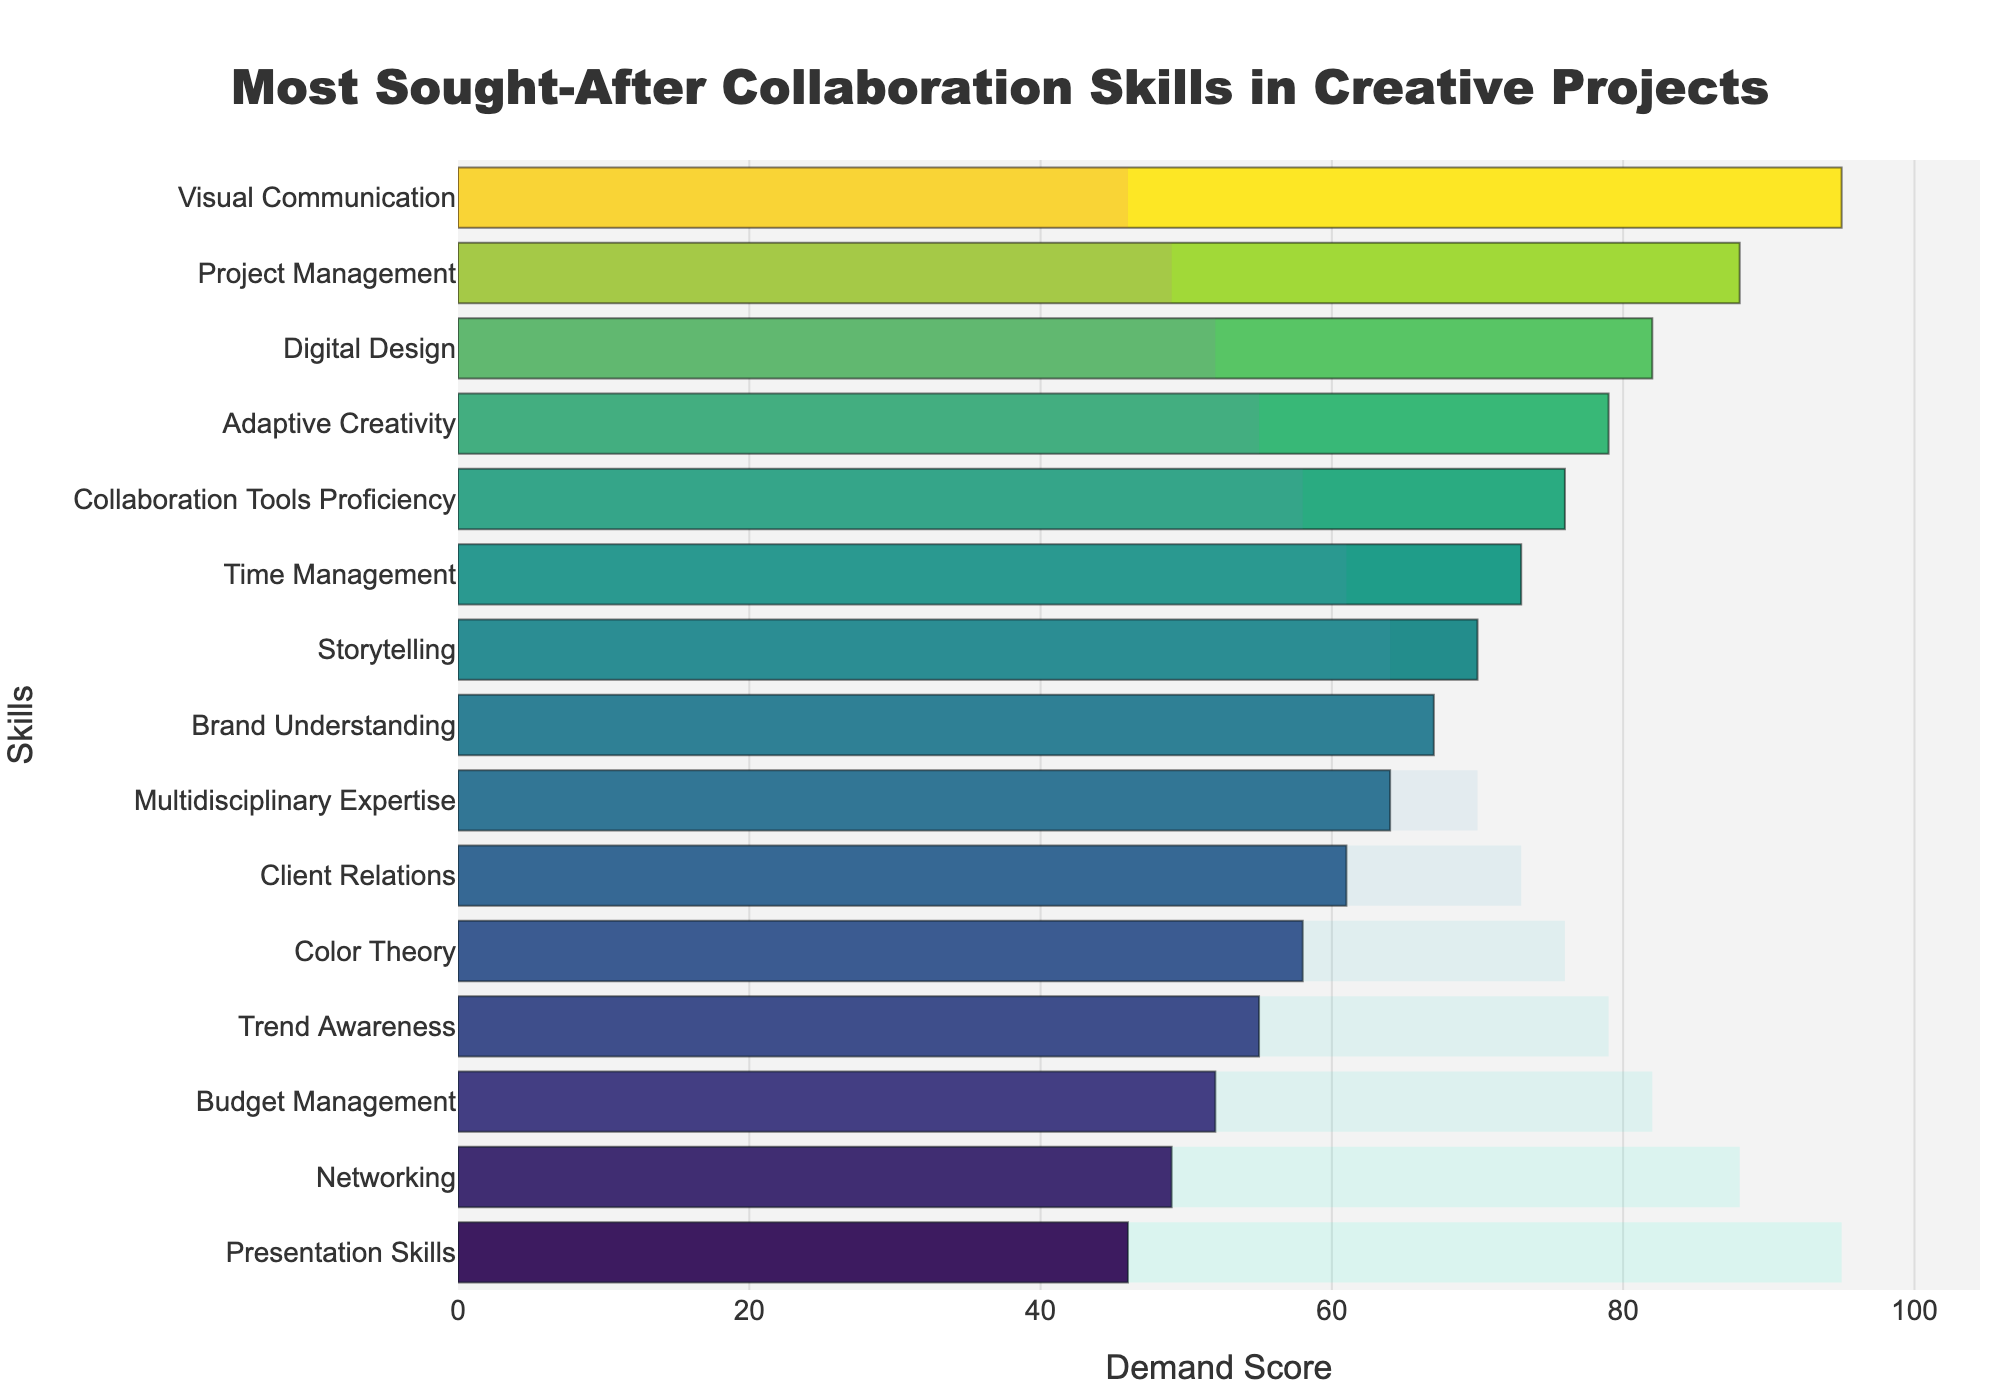what is the most sought-after collaboration skill? The bar representing "Visual Communication" has the highest demand score of 95, making it the most sought-after skill.
Answer: Visual Communication Which skill has the lowest demand score? By observing the bars, "Presentation Skills" has the shortest bar with a demand score of 46, making it the skill with the lowest demand.
Answer: Presentation Skills What is the average demand score of the top 3 skills? Add the demand scores of the top three skills: Visual Communication (95), Project Management (88), and Digital Design (82). The total is 265. Then, divide by 3.
Answer: 88.3 How does the demand score of Adaptive Creativity compare to Digital Design? From the visualization, Digital Design has a score of 82, and Adaptive Creativity has a score of 79. Adaptive Creativity's score is 3 points lower.
Answer: Digital Design has 3 points more What’s the difference in demand score between the top and bottom skills? The top skill, Visual Communication, has a score of 95. The bottom skill, Presentation Skills, has a score of 46. The difference is 95 - 46.
Answer: 49 Which skills have a demand score greater than 80? From the bar chart, the skills with scores above 80 are "Visual Communication" (95), "Project Management" (88), and "Digital Design" (82).
Answer: Visual Communication, Project Management, Digital Design How many skills have a demand score lower than 60? Check the bars in the figure to see which ones are below 60. They are "Color Theory" (58), "Trend Awareness" (55), "Budget Management" (52), "Networking" (49), and "Presentation Skills" (46).
Answer: 5 What’s the sum of the demand scores for Collaboration Tools Proficiency and Brand Understanding? Collaboration Tools Proficiency has a score of 76, and Brand Understanding has a score of 67. The sum is 76 + 67.
Answer: 143 What is the median demand score of all the skills? Order the skills' demand scores and find the middle value. The ordered scores are 46, 49, 52, 55, 58, 61, 64, 67, 70, 73, 76, 79, 82, 88, 95. The middle value (8th in a list of 15) is 67.
Answer: 67 What visual attribute indicates higher demand scores in the chart? Higher demand scores are represented by longer bars, with the colors shifting to a darker green as scores increase.
Answer: Longer bars, darker green 